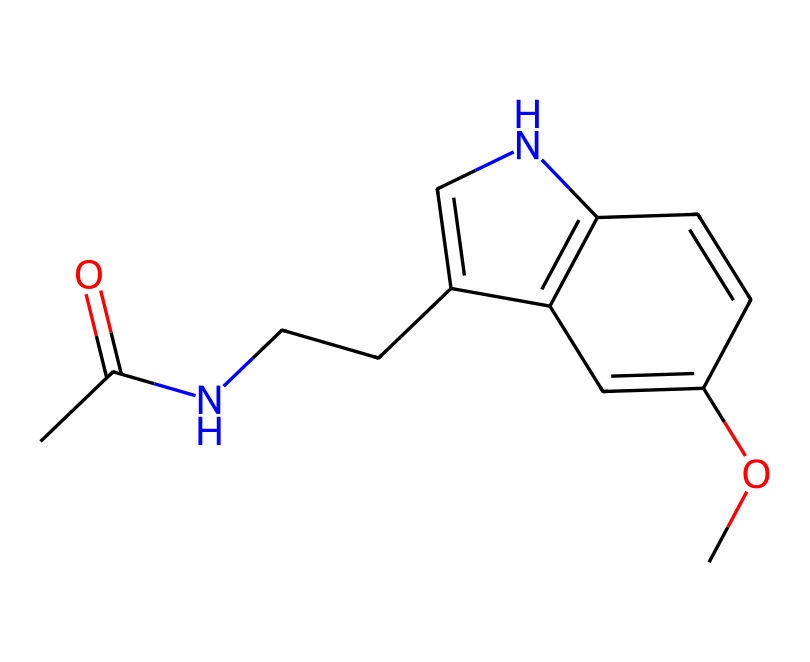What is the main functional group present in this molecule? The molecule contains an amide functional group characterized by the presence of a carbonyl (C=O) directly attached to a nitrogen atom (N). This is visible in the structure as part of the sequence.
Answer: amide How many nitrogen atoms are in this chemical structure? By analyzing the structure, there is one nitrogen atom present in the amide functional group, which can be clearly identified in the structure.
Answer: one Does this molecule contain any double bonds? Yes, the structure clearly includes multiple double bonds indicated by the "=" signs in the SMILES representation, especially between carbon atoms, reflecting its unsaturated nature.
Answer: yes What type of molecule is melatonin classified as? Melatonin is classified as an indoleamine due to its structure that features an indole ring (a fused bicyclic structure containing both a six-membered and a five-membered ring) along with an amine group.
Answer: indoleamine How many carbon atoms are present in this molecule? Counting from the SMILES representation, there are 13 carbon atoms in total within the structure, which can be confirmed by identifying each "C" in the sequence.
Answer: thirteen What is a potential effect of melatonin on sleep regulation? Melatonin influences the sleep-wake cycle by signaling the body to prepare for sleep, which can be particularly important for individuals like DJs who may experience disrupted sleep patterns due to late-night performances.
Answer: regulate sleep 